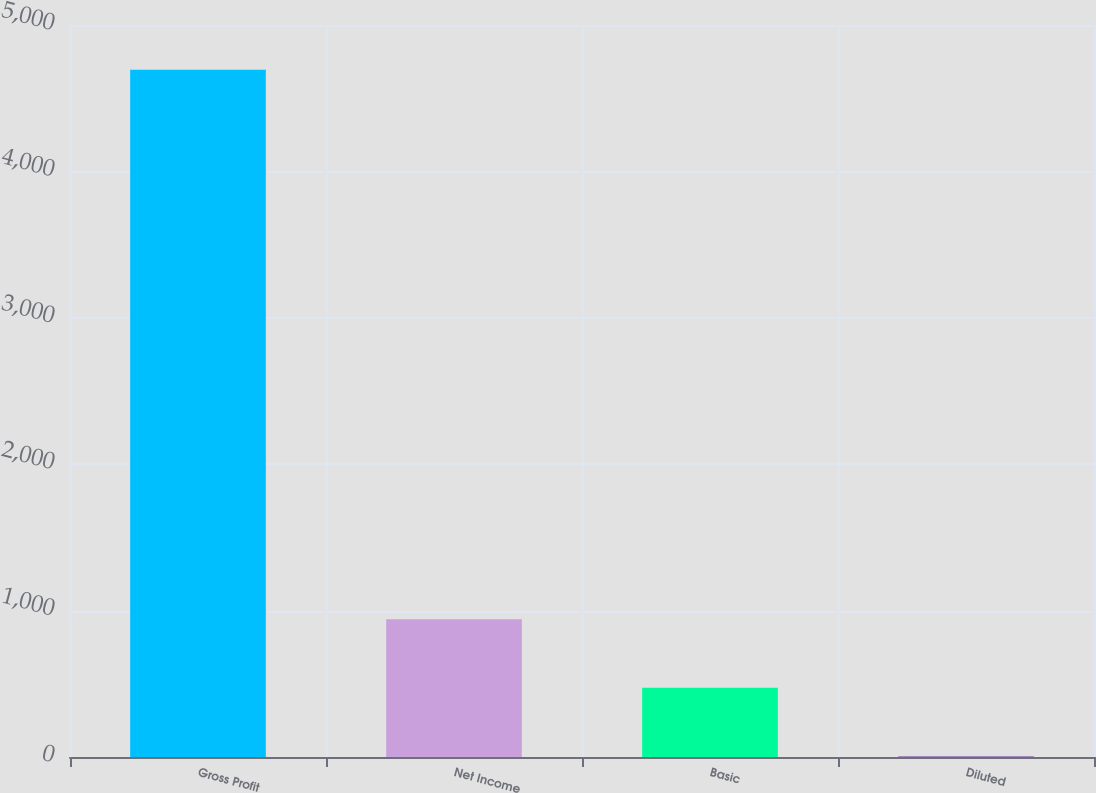<chart> <loc_0><loc_0><loc_500><loc_500><bar_chart><fcel>Gross Profit<fcel>Net Income<fcel>Basic<fcel>Diluted<nl><fcel>4695<fcel>941.67<fcel>472.51<fcel>3.35<nl></chart> 